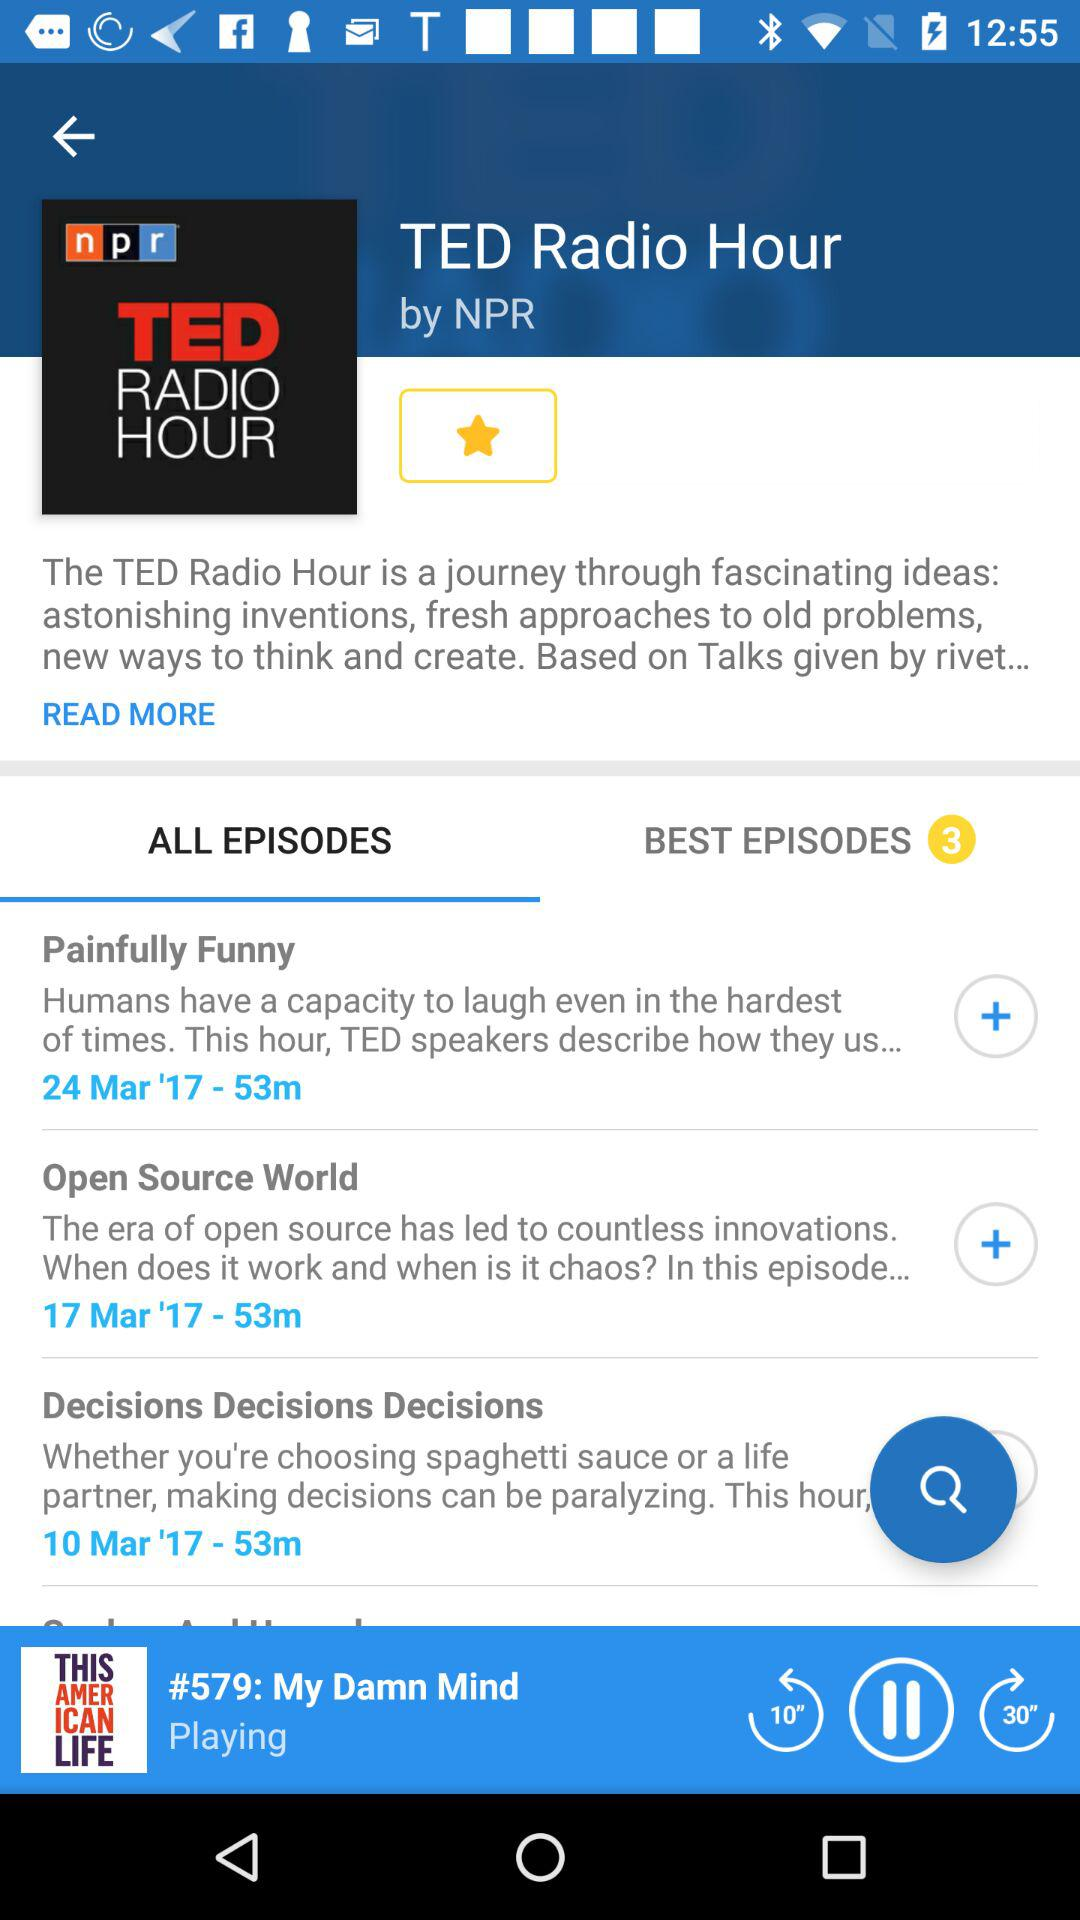What is the duration of the episodes? The duration of the episodes is 53 minutes. 